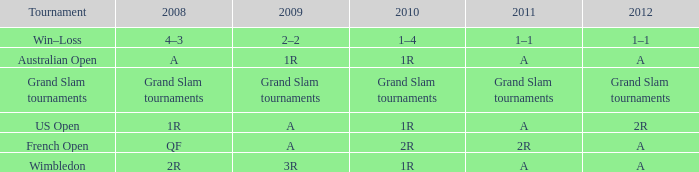Name the 2010 for tournament of us open 1R. 